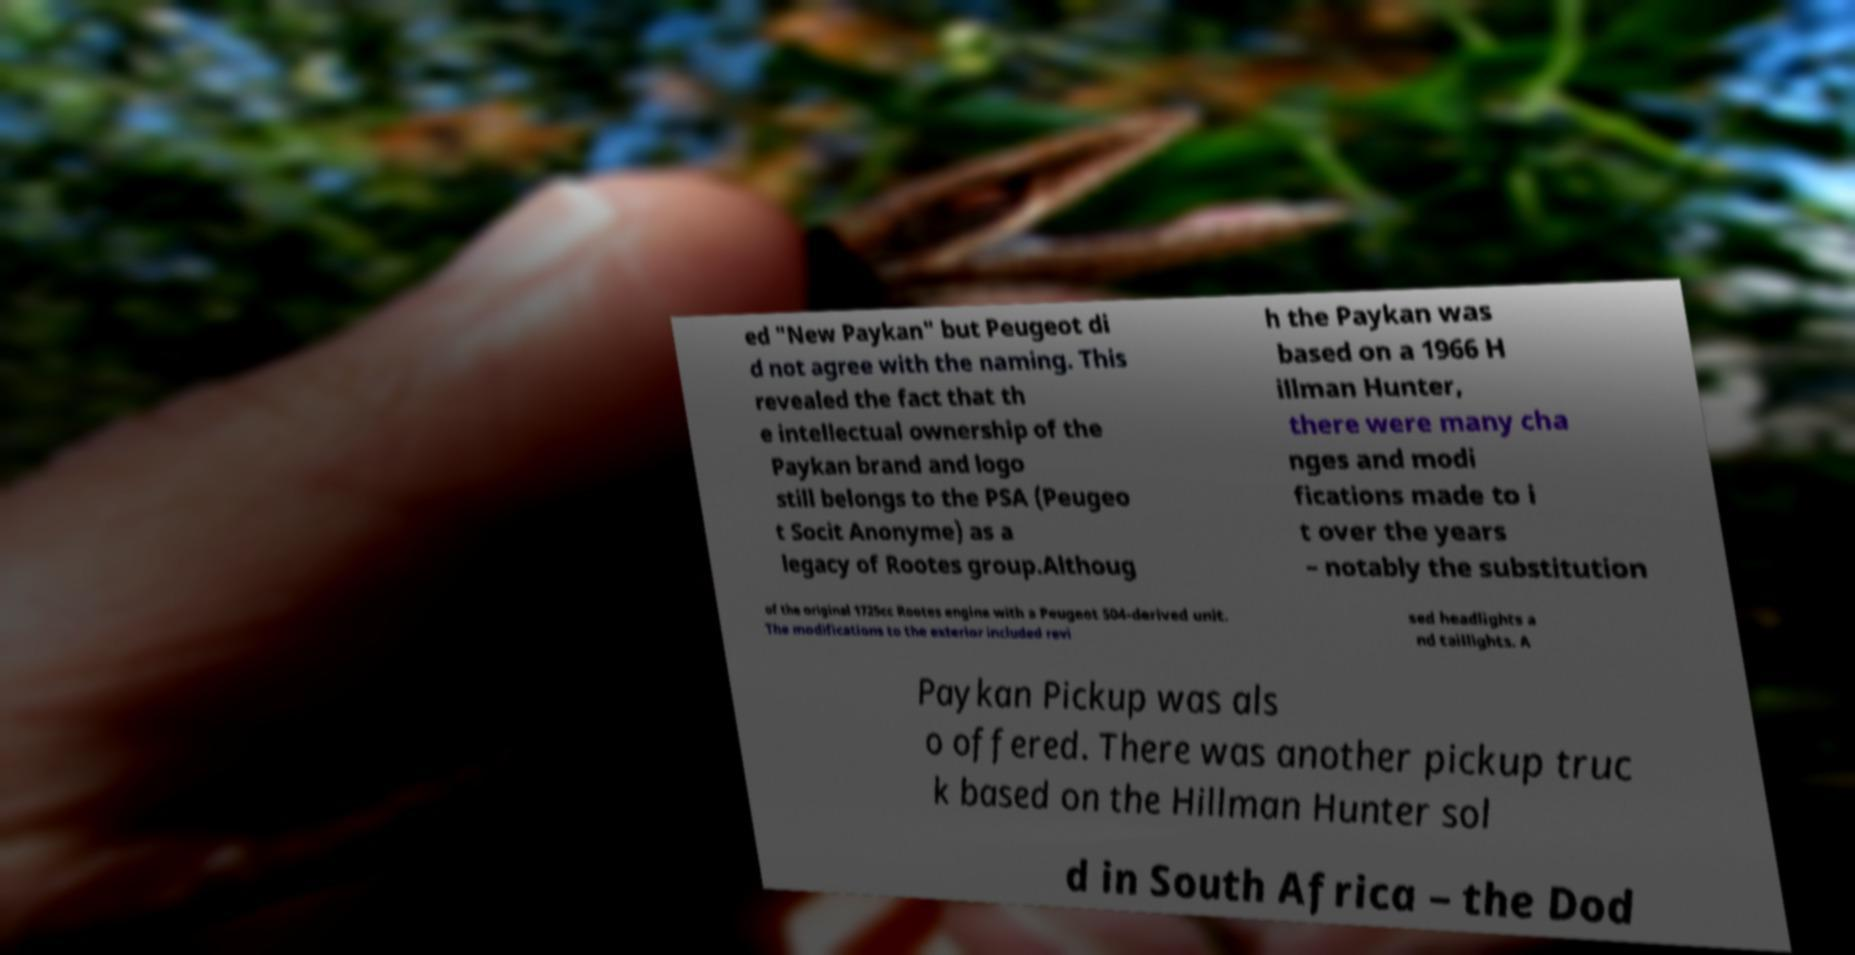I need the written content from this picture converted into text. Can you do that? ed "New Paykan" but Peugeot di d not agree with the naming. This revealed the fact that th e intellectual ownership of the Paykan brand and logo still belongs to the PSA (Peugeo t Socit Anonyme) as a legacy of Rootes group.Althoug h the Paykan was based on a 1966 H illman Hunter, there were many cha nges and modi fications made to i t over the years – notably the substitution of the original 1725cc Rootes engine with a Peugeot 504-derived unit. The modifications to the exterior included revi sed headlights a nd taillights. A Paykan Pickup was als o offered. There was another pickup truc k based on the Hillman Hunter sol d in South Africa – the Dod 